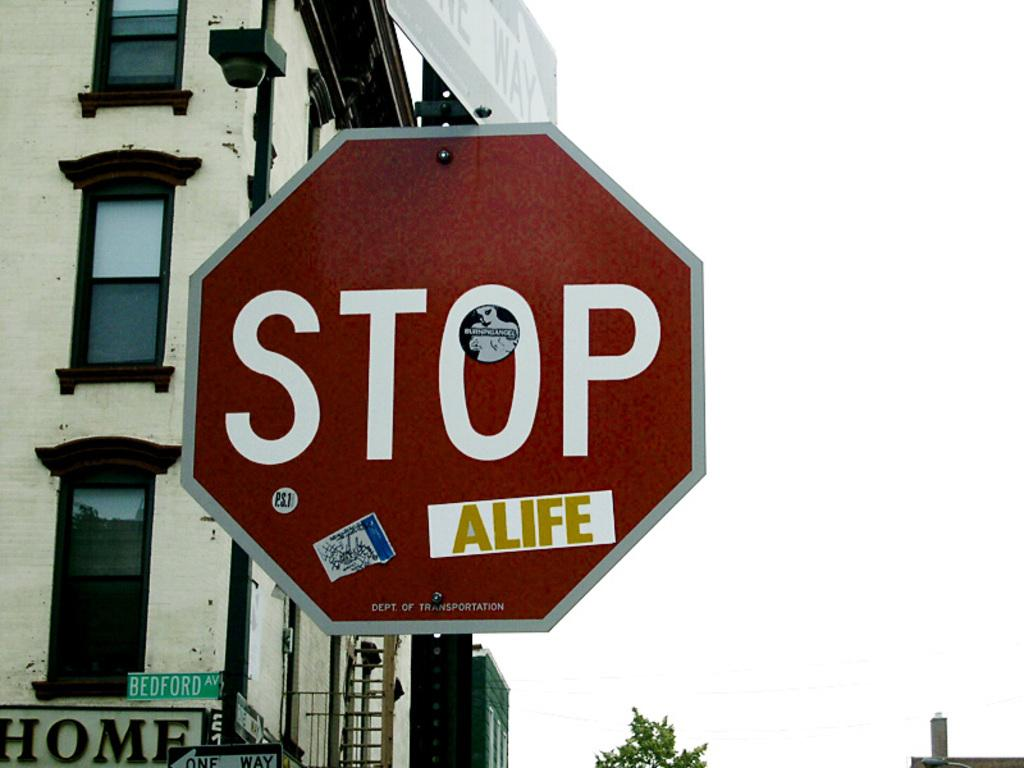What is the main structure in the image? There is a pole with boards in the image. What is written or depicted on the boards? There is text on the boards. What can be seen in the background of the image? There are two buildings visible behind the boards. What is visible in the sky in the image? The sky is visible in the image. How many sets of boards are there in the image? There are additional boards at the bottom of the image. What type of vegetation is visible at the bottom of the image? There is a tree visible at the bottom of the image. What type of quiver is hanging from the tree at the bottom of the image? There is no quiver present in the image; it features a pole with boards, text, buildings, and a tree. What type of fuel is being used by the society depicted in the image? There is no society or fuel mentioned in the image; it only shows a pole with boards, text, buildings, and a tree. 